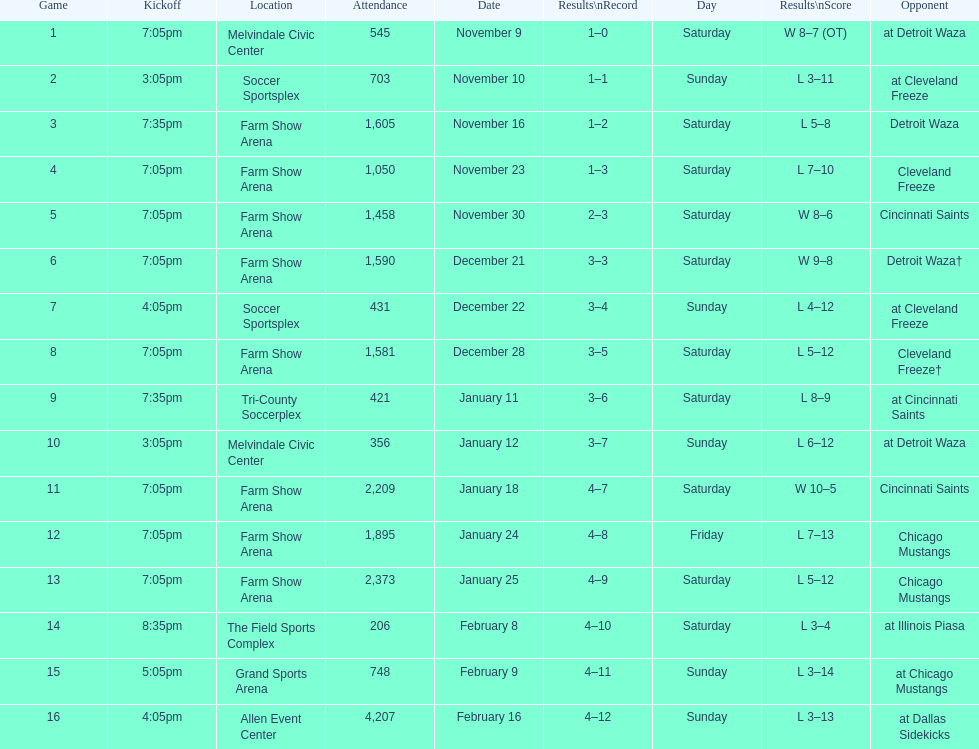How many times did the team participate at home without securing a win? 5. 